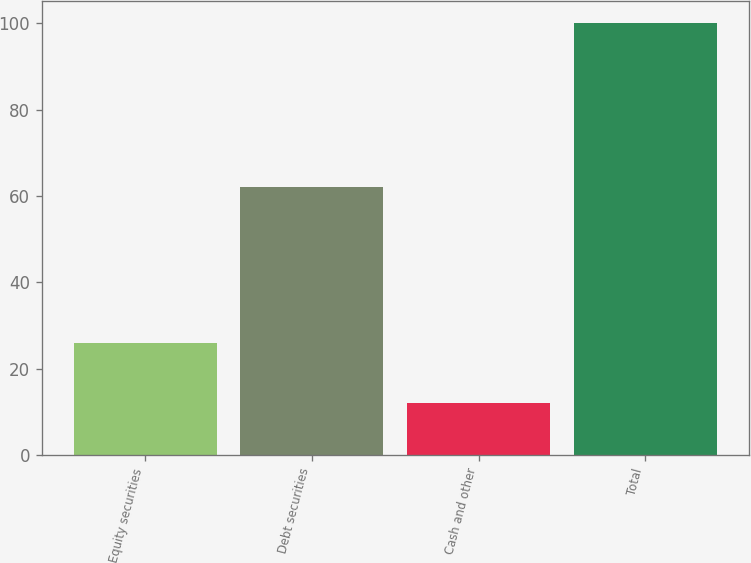Convert chart. <chart><loc_0><loc_0><loc_500><loc_500><bar_chart><fcel>Equity securities<fcel>Debt securities<fcel>Cash and other<fcel>Total<nl><fcel>26<fcel>62<fcel>12<fcel>100<nl></chart> 